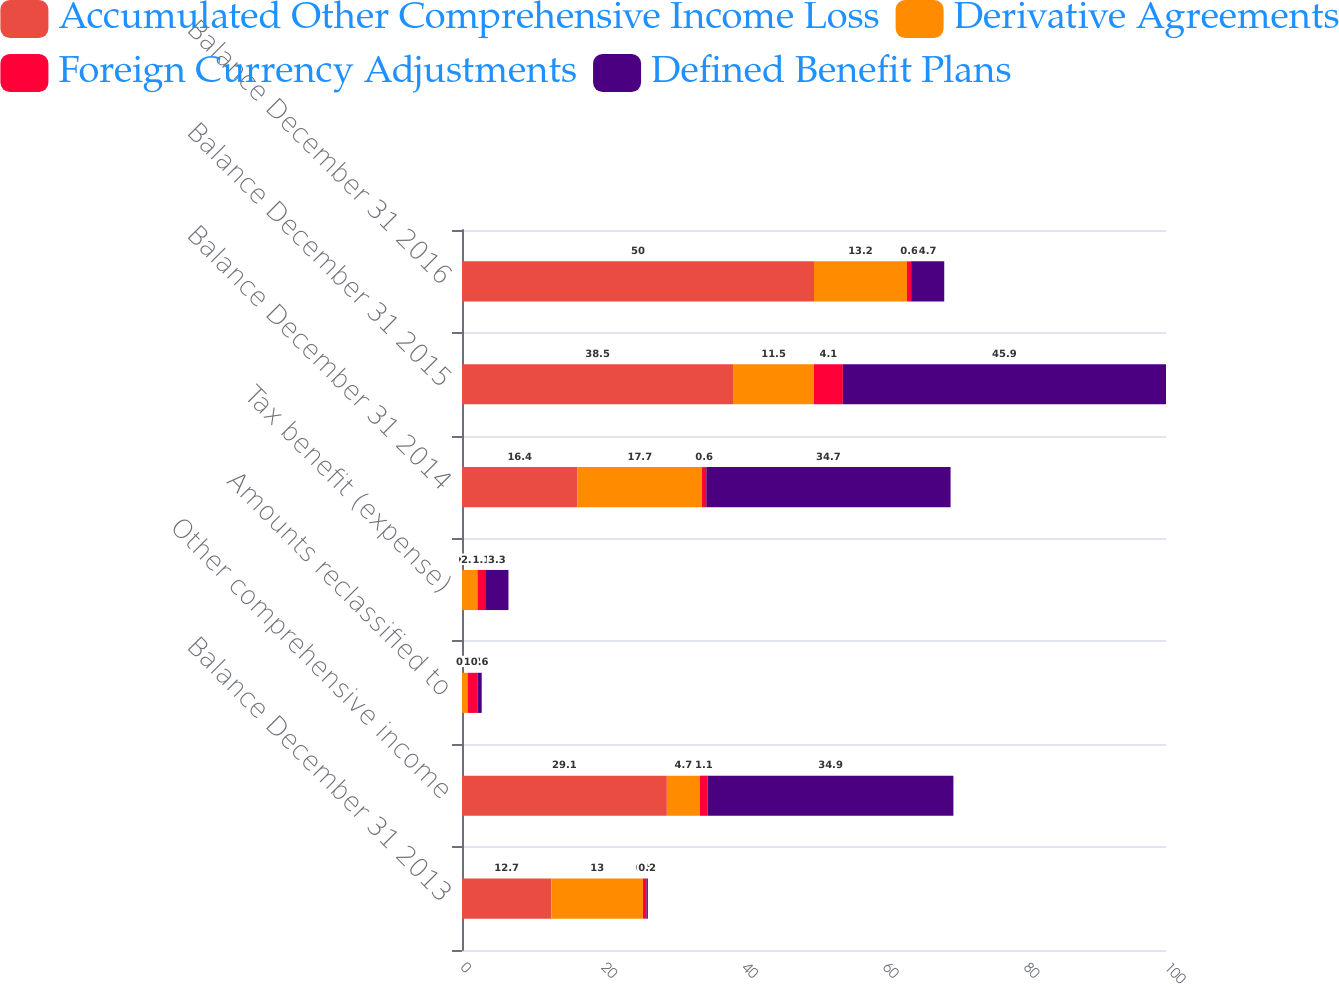Convert chart to OTSL. <chart><loc_0><loc_0><loc_500><loc_500><stacked_bar_chart><ecel><fcel>Balance December 31 2013<fcel>Other comprehensive income<fcel>Amounts reclassified to<fcel>Tax benefit (expense)<fcel>Balance December 31 2014<fcel>Balance December 31 2015<fcel>Balance December 31 2016<nl><fcel>Accumulated Other Comprehensive Income Loss<fcel>12.7<fcel>29.1<fcel>0<fcel>0<fcel>16.4<fcel>38.5<fcel>50<nl><fcel>Derivative Agreements<fcel>13<fcel>4.7<fcel>0.8<fcel>2.2<fcel>17.7<fcel>11.5<fcel>13.2<nl><fcel>Foreign Currency Adjustments<fcel>0.5<fcel>1.1<fcel>1.4<fcel>1.1<fcel>0.6<fcel>4.1<fcel>0.6<nl><fcel>Defined Benefit Plans<fcel>0.2<fcel>34.9<fcel>0.6<fcel>3.3<fcel>34.7<fcel>45.9<fcel>4.7<nl></chart> 